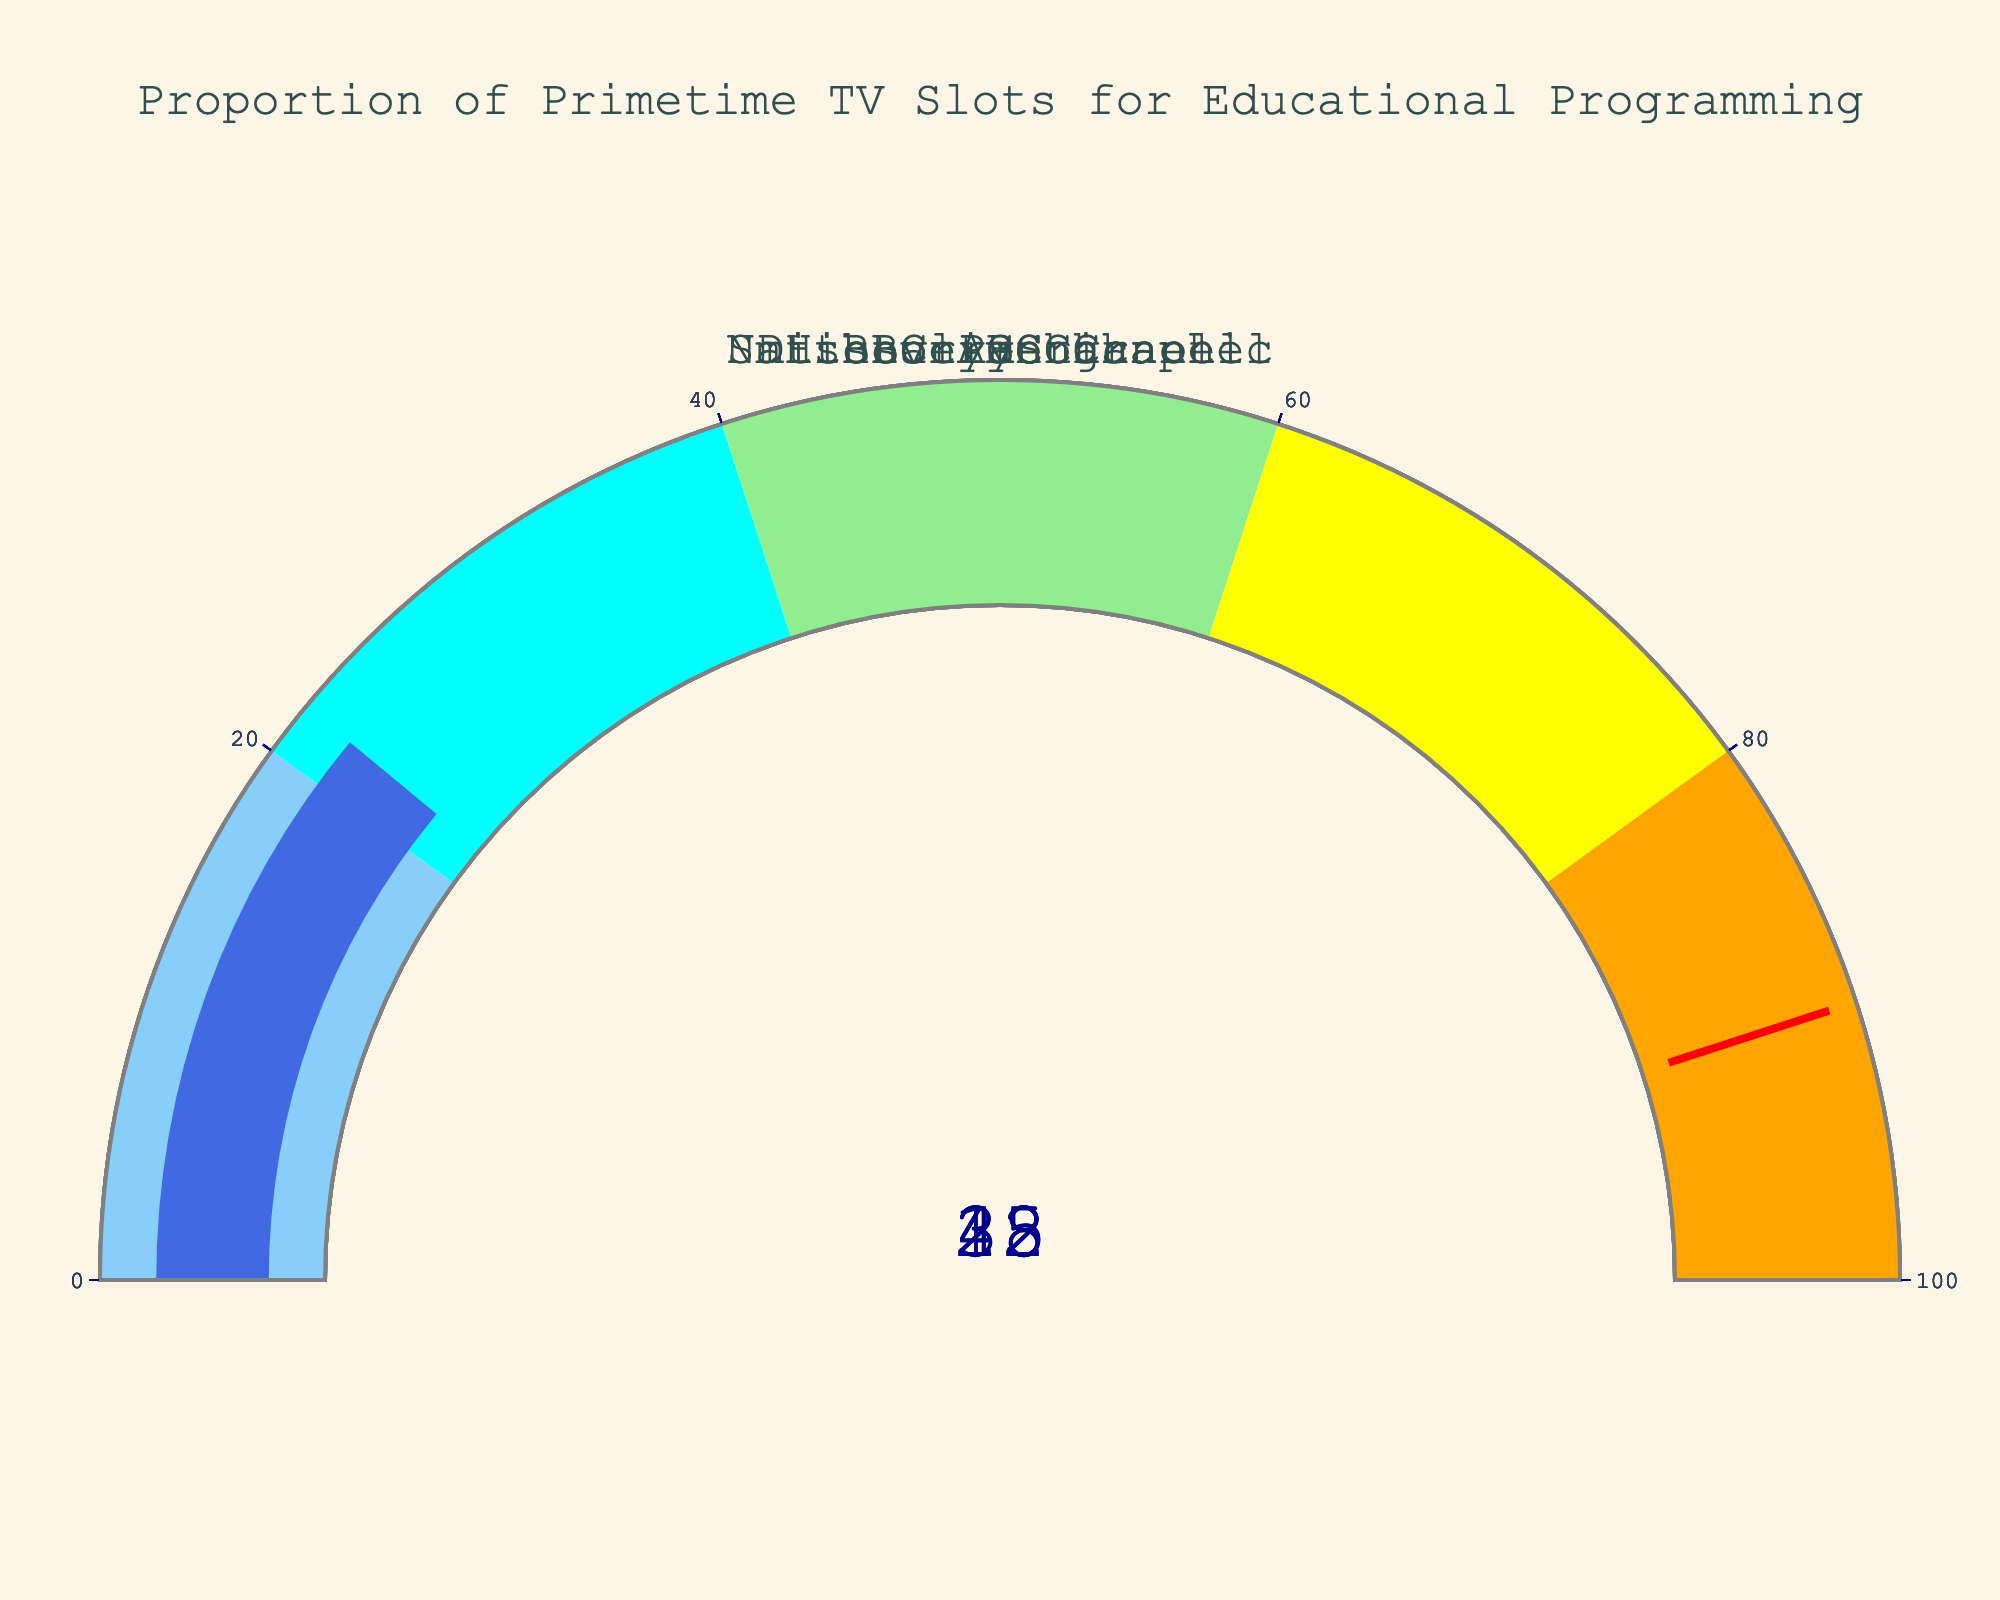Which channel has the highest percentage of primetime television slots dedicated to educational programming? Looking at the percentage values on the gauges, the Smithsonian Channel has the highest value of 45%.
Answer: Smithsonian Channel What is the lowest proportion of primetime television slots dedicated to educational programming among the channels? Observing the gauges, the History Channel has the lowest value of 18%.
Answer: History Channel How many channels have more than 30% of their primetime slots dedicated to educational programming? PBS, Smithsonian Channel, and National Geographic have values above 30% (42%, 45%, and 35% respectively). Therefore, three channels meet this criterion.
Answer: 3 What is the average percentage of primetime television slots dedicated to educational programming across all channels? Summing the percentages: 42 + 28 + 18 + 35 + 45 + 22 = 190, then dividing by the number of channels (6), the average is 190/6 ≈ 31.67%.
Answer: 31.67% Which channel has a percentage closest to the average value? The average percentage is approximately 31.67%. Comparing this value with each channel's percentage, the Discovery Channel with 28% is the closest.
Answer: Discovery Channel What is the range of the percentages of primetime television slots dedicated to educational programming? The highest percentage is 45% (Smithsonian Channel) and the lowest is 18% (History Channel). The range is 45 - 18 = 27%.
Answer: 27% Is there any channel that has exactly 40% of its primetime slots dedicated to educational programming? Checking all percentage values on the gauges, none of the channels have a value of exactly 40%.
Answer: No How much higher is the Smithsonian Channel's percentage compared to BBC America's? The Smithsonian Channel has 45% and BBC America has 22%. The difference is 45% - 22% = 23%.
Answer: 23% What is the median percentage of primetime television slots dedicated to educational programming? Listing the percentages in order: 18, 22, 28, 35, 42, 45. The median is the average of the middle two values (28 and 35), so (28 + 35) / 2 = 31.5%.
Answer: 31.5% What proportion of channels have less than 30% of their primetime television slots dedicated to educational programming? There are six channels total, and three of them (Discovery Channel, History Channel, BBC America) have less than 30%. The proportion is 3/6 = 0.5 or 50%.
Answer: 50% 